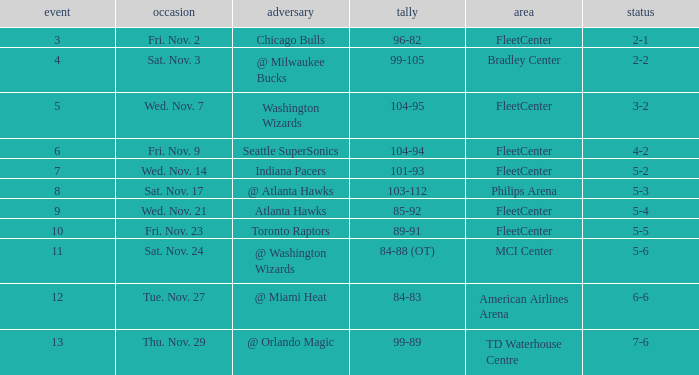On what date did a game higher than 10 have a score of 99-89? Thu. Nov. 29. 